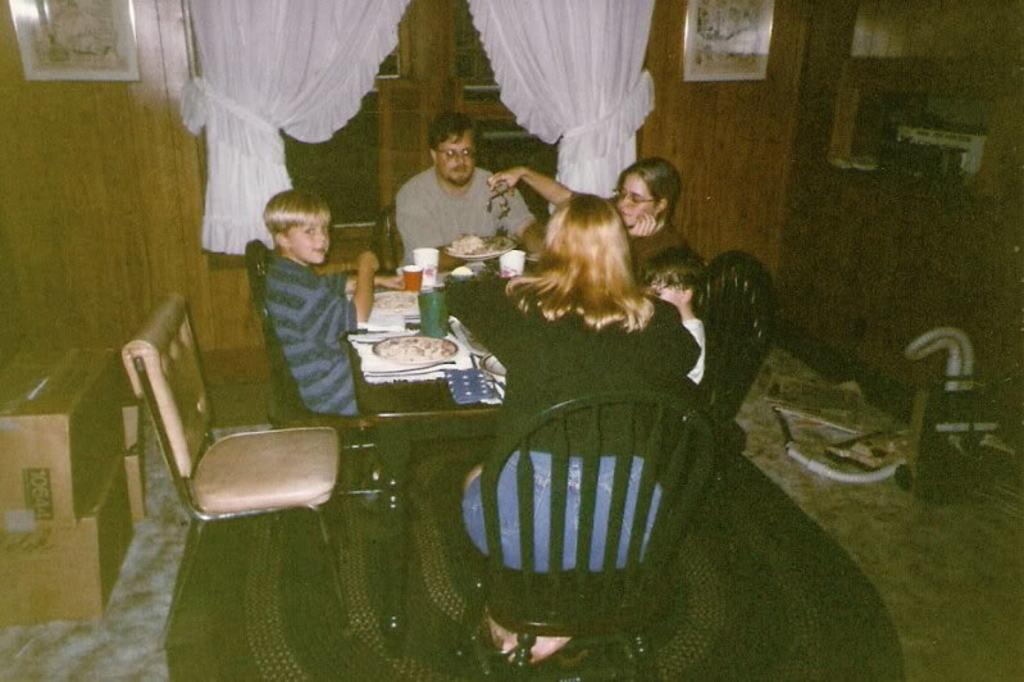How many people are present in the image? There are five people in the image. What are the people doing in the image? The people are sitting on chairs. Where are the chairs located in relation to the dining table? The chairs are arranged around a dining table. What can be seen on the windows in the image? There are two white curtains on the windows. What is on the floor in the image? There are boxes on the floor. What type of animal is sitting on the drawer in the image? There is no drawer or animal present in the image. 